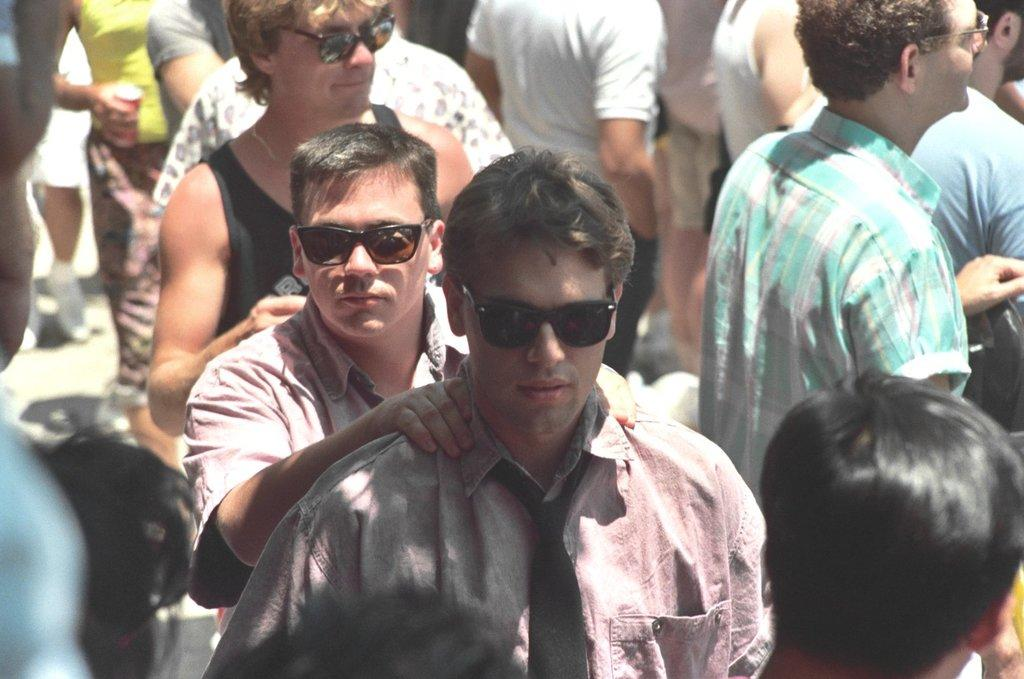How many people are in the image? There is a group of people in the image. What is the position of the people in the image? The people are standing on the ground. Can you describe the woman holding an object in her hand? One woman is holding an object in her hand. What type of rose can be seen growing on the railway tracks in the image? There is no rose or railway tracks present in the image. 